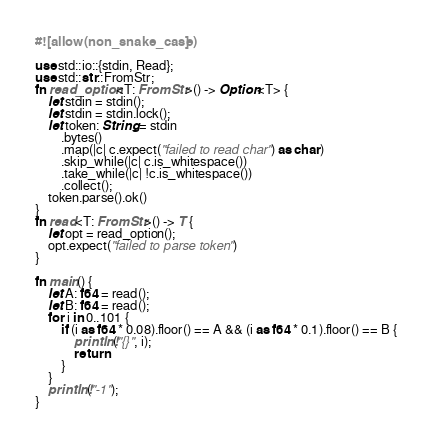Convert code to text. <code><loc_0><loc_0><loc_500><loc_500><_Rust_>#![allow(non_snake_case)]

use std::io::{stdin, Read};
use std::str::FromStr;
fn read_option<T: FromStr>() -> Option<T> {
    let stdin = stdin();
    let stdin = stdin.lock();
    let token: String = stdin
        .bytes()
        .map(|c| c.expect("failed to read char") as char)
        .skip_while(|c| c.is_whitespace())
        .take_while(|c| !c.is_whitespace())
        .collect();
    token.parse().ok()
}
fn read<T: FromStr>() -> T {
    let opt = read_option();
    opt.expect("failed to parse token")
}

fn main() {
    let A: f64 = read();
    let B: f64 = read();
    for i in 0..101 {
        if (i as f64 * 0.08).floor() == A && (i as f64 * 0.1).floor() == B {
            println!("{}", i);
            return
        }
    }
    println!("-1");
}
</code> 